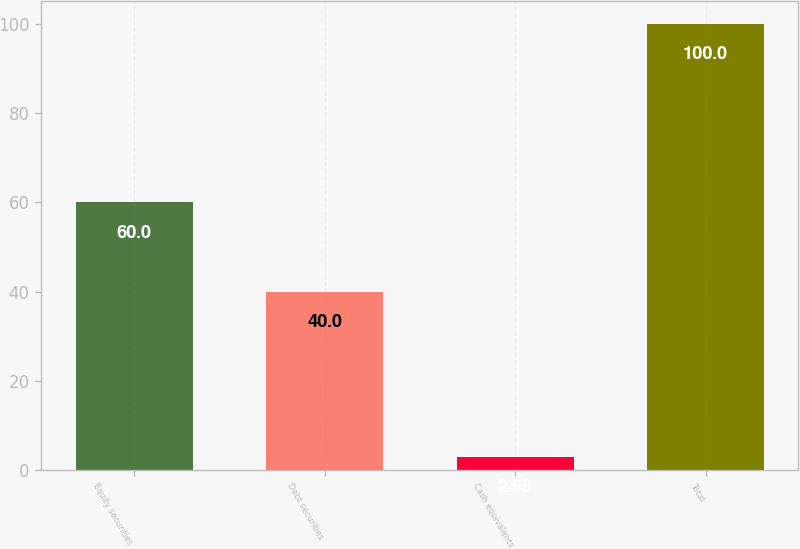Convert chart. <chart><loc_0><loc_0><loc_500><loc_500><bar_chart><fcel>Equity securities<fcel>Debt securities<fcel>Cash equivalents<fcel>Total<nl><fcel>60<fcel>40<fcel>2.98<fcel>100<nl></chart> 